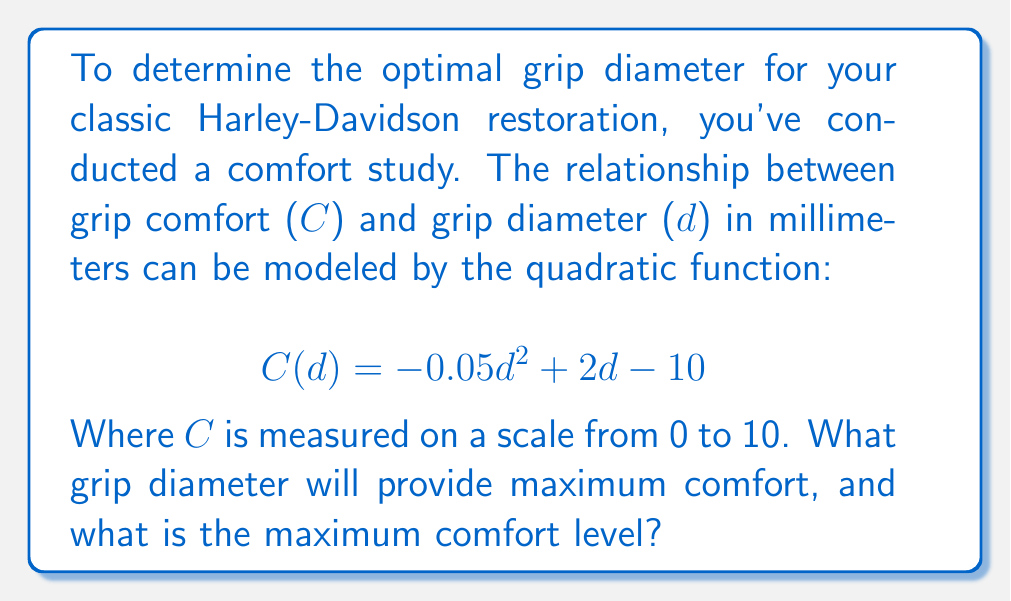Solve this math problem. To find the maximum comfort and corresponding grip diameter, we need to follow these steps:

1) The quadratic function is in the form $f(x) = ax^2 + bx + c$, where $a = -0.05$, $b = 2$, and $c = -10$.

2) For a quadratic function, the x-coordinate of the vertex represents the value of x where the function reaches its maximum (if $a < 0$) or minimum (if $a > 0$).

3) The formula for the x-coordinate of the vertex is $x = -\frac{b}{2a}$. Let's calculate this:

   $$d = -\frac{2}{2(-0.05)} = -\frac{2}{-0.1} = 20$$

4) So, the grip diameter that provides maximum comfort is 20 mm.

5) To find the maximum comfort level, we substitute this d value into the original function:

   $$C(20) = -0.05(20)^2 + 2(20) - 10$$
   $$= -0.05(400) + 40 - 10$$
   $$= -20 + 40 - 10$$
   $$= 10$$

Therefore, the maximum comfort level is 10 on the 0-10 scale.
Answer: 20 mm diameter; 10 comfort level 